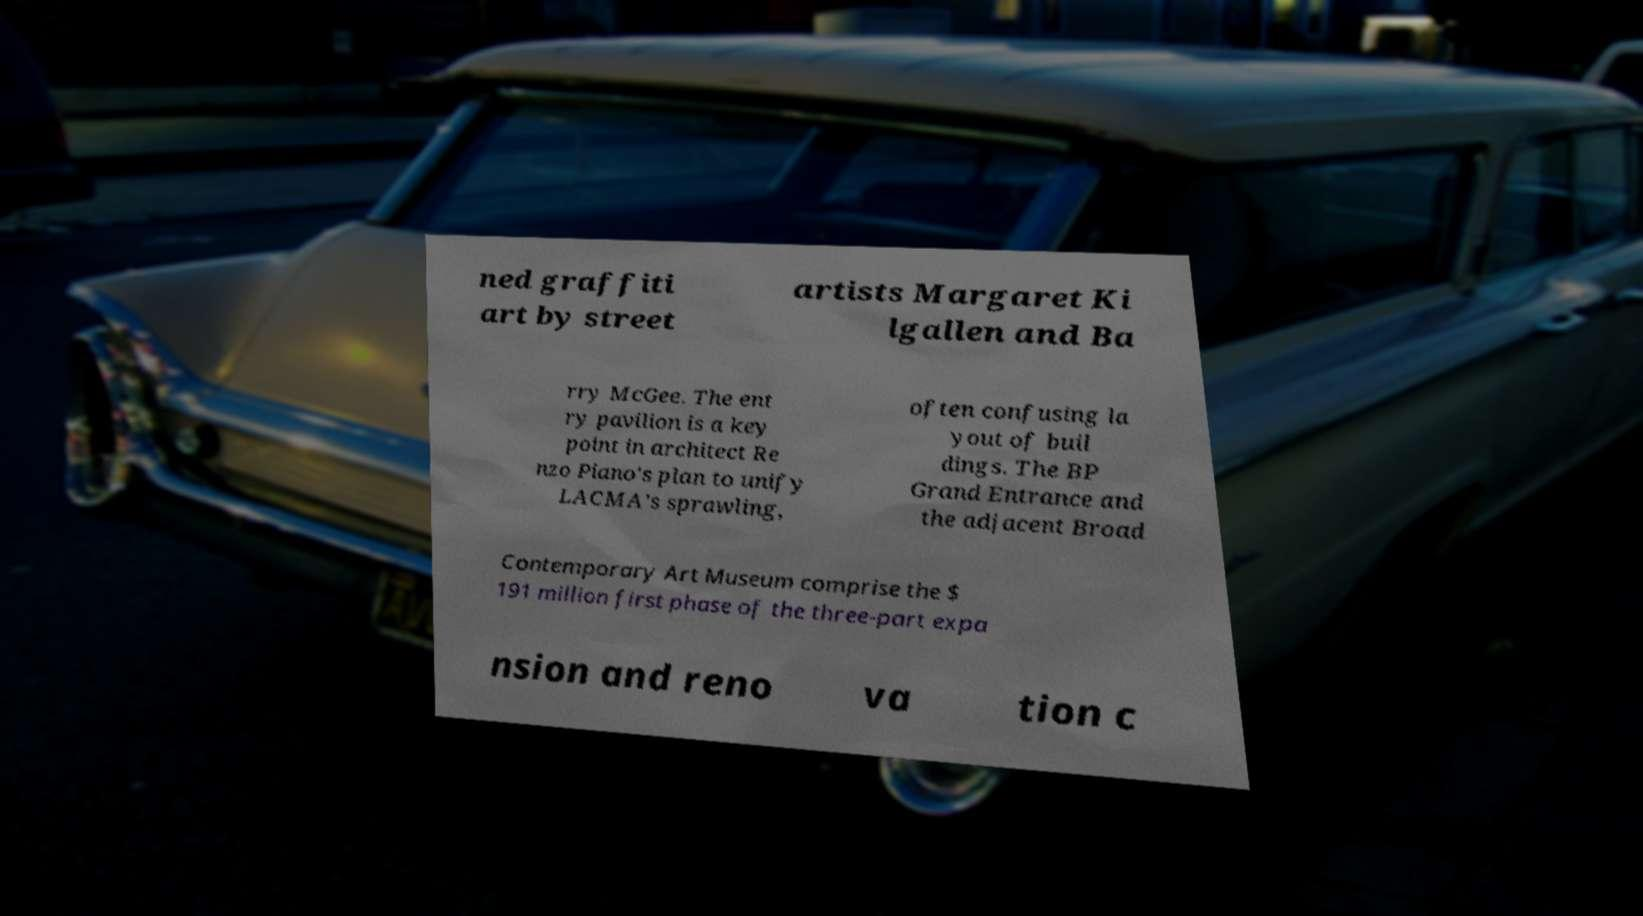For documentation purposes, I need the text within this image transcribed. Could you provide that? ned graffiti art by street artists Margaret Ki lgallen and Ba rry McGee. The ent ry pavilion is a key point in architect Re nzo Piano's plan to unify LACMA's sprawling, often confusing la yout of buil dings. The BP Grand Entrance and the adjacent Broad Contemporary Art Museum comprise the $ 191 million first phase of the three-part expa nsion and reno va tion c 